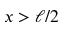Convert formula to latex. <formula><loc_0><loc_0><loc_500><loc_500>x > \ell / 2</formula> 